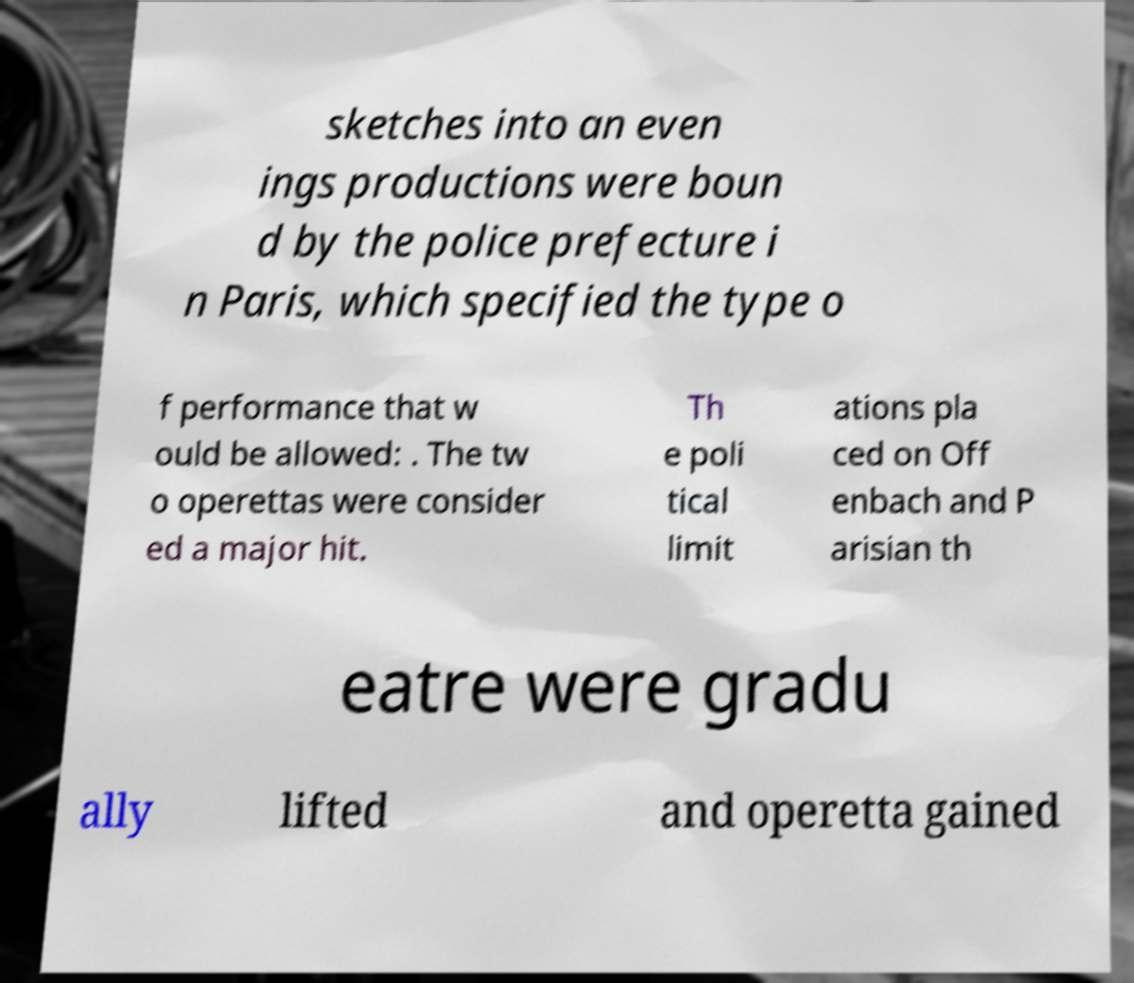Can you read and provide the text displayed in the image?This photo seems to have some interesting text. Can you extract and type it out for me? sketches into an even ings productions were boun d by the police prefecture i n Paris, which specified the type o f performance that w ould be allowed: . The tw o operettas were consider ed a major hit. Th e poli tical limit ations pla ced on Off enbach and P arisian th eatre were gradu ally lifted and operetta gained 